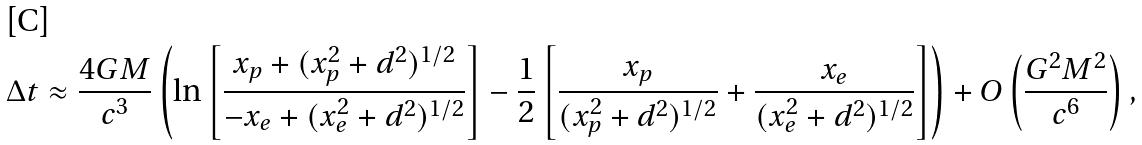<formula> <loc_0><loc_0><loc_500><loc_500>\Delta t \approx { \frac { 4 G M } { c ^ { 3 } } } \left ( \ln \left [ { \frac { x _ { p } + ( x _ { p } ^ { 2 } + d ^ { 2 } ) ^ { 1 / 2 } } { - x _ { e } + ( x _ { e } ^ { 2 } + d ^ { 2 } ) ^ { 1 / 2 } } } \right ] - { \frac { 1 } { 2 } } \left [ { \frac { x _ { p } } { ( x _ { p } ^ { 2 } + d ^ { 2 } ) ^ { 1 / 2 } } } + { \frac { x _ { e } } { ( x _ { e } ^ { 2 } + d ^ { 2 } ) ^ { 1 / 2 } } } \right ] \right ) + O \left ( { \frac { G ^ { 2 } M ^ { 2 } } { c ^ { 6 } } } \right ) ,</formula> 